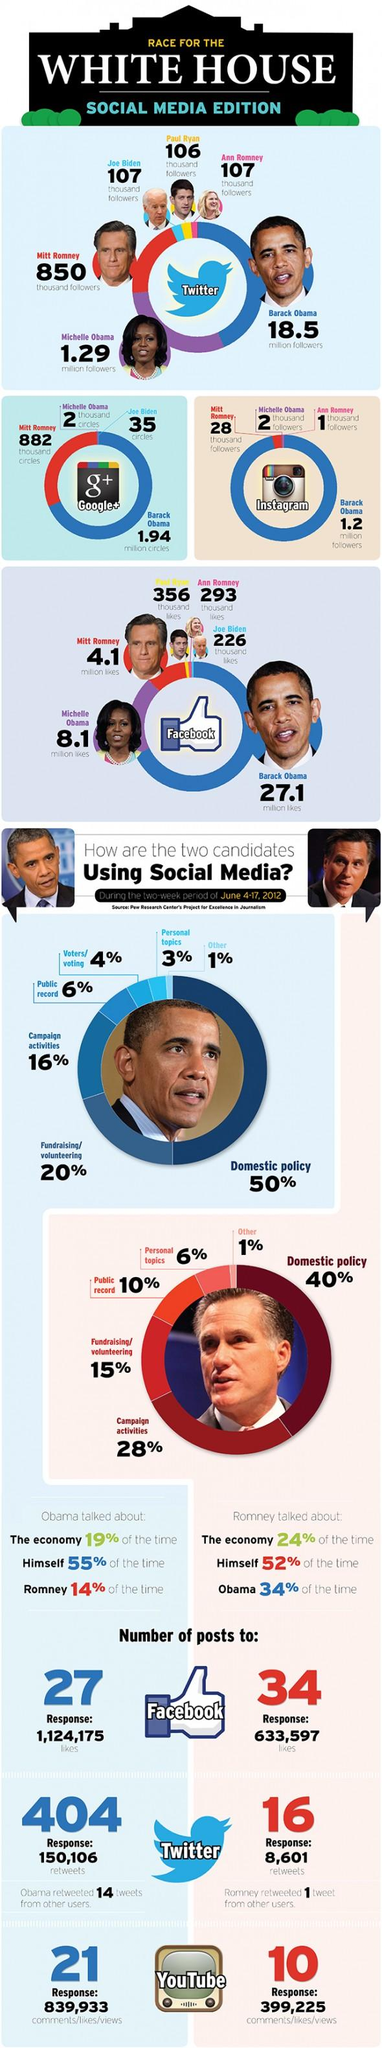Point out several critical features in this image. According to the infographic, Mitt Romney posted more on Facebook during the specified period. Michelle Obama has the third largest number of Instagram followers in the White House. In an analysis of Mitt Romney's use of social media for his 2012 presidential campaign, it was found that 44% of his social media activity was dedicated to fundraising, volunteering, or campaigning. According to estimates, Romney spent approximately 60% of his time on social media discussing issues related to foreign policy, as opposed to domestic policy. In social media, Mitt Romney spent 86% of his time discussing himself or President Obama. 